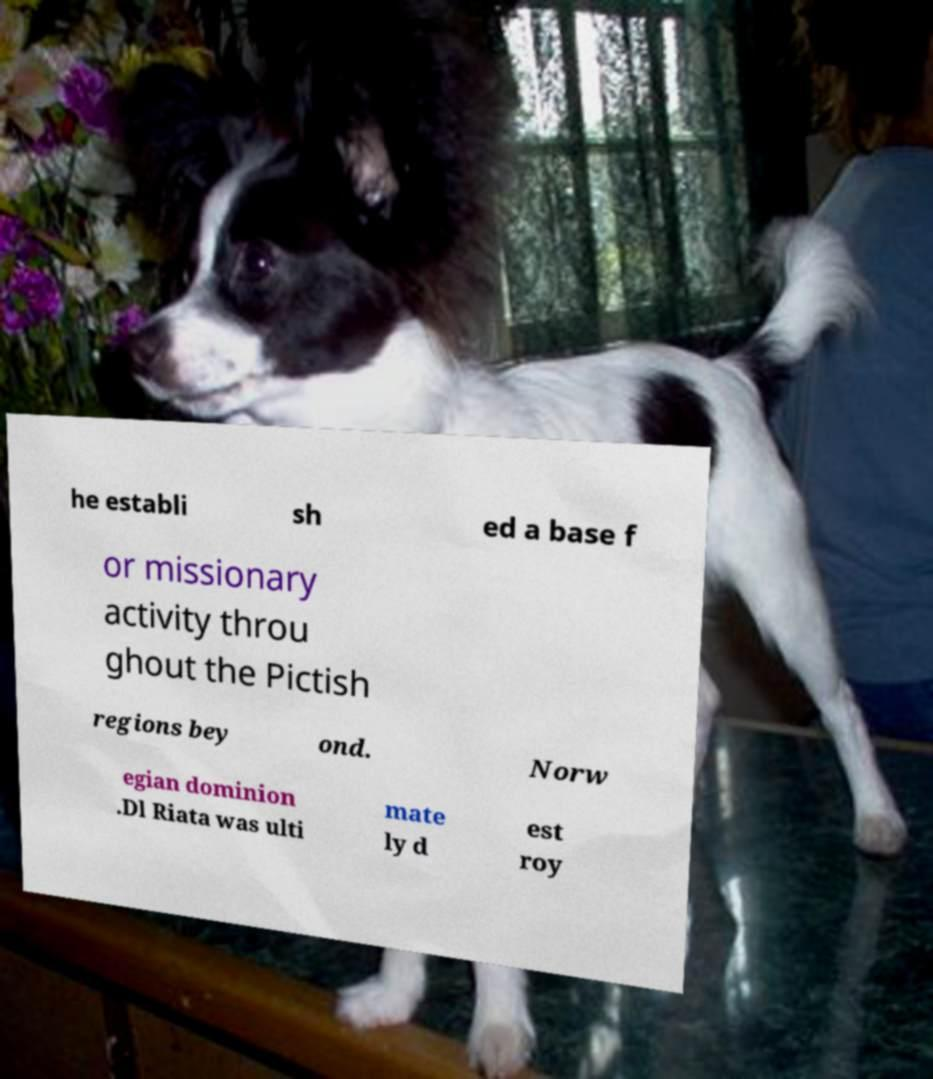What messages or text are displayed in this image? I need them in a readable, typed format. he establi sh ed a base f or missionary activity throu ghout the Pictish regions bey ond. Norw egian dominion .Dl Riata was ulti mate ly d est roy 